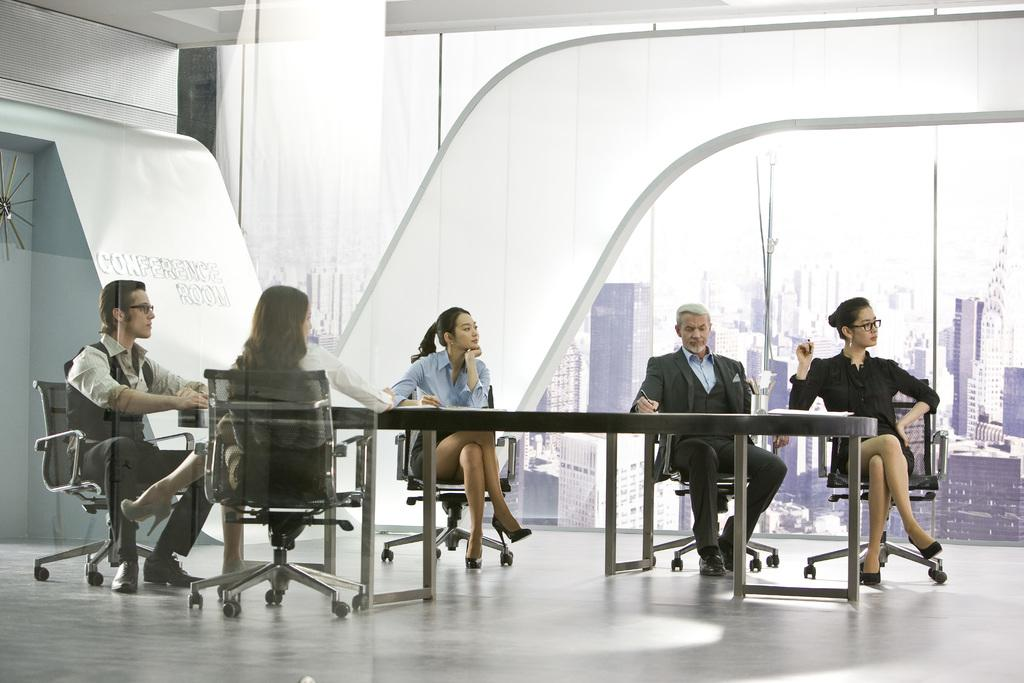How many people are in the image? There are 5 persons in the image. What are the persons doing in the image? The persons are sitting on chairs. What is in front of the persons? There is a table in front of the persons. What can be seen in the background of the image? There are buildings in the background of the image. What type of cub can be seen in the image? There is no cub present in the image. 